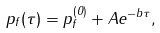<formula> <loc_0><loc_0><loc_500><loc_500>p _ { f } ( \tau ) = p _ { f } ^ { ( 0 ) } + A e ^ { - b \tau } ,</formula> 